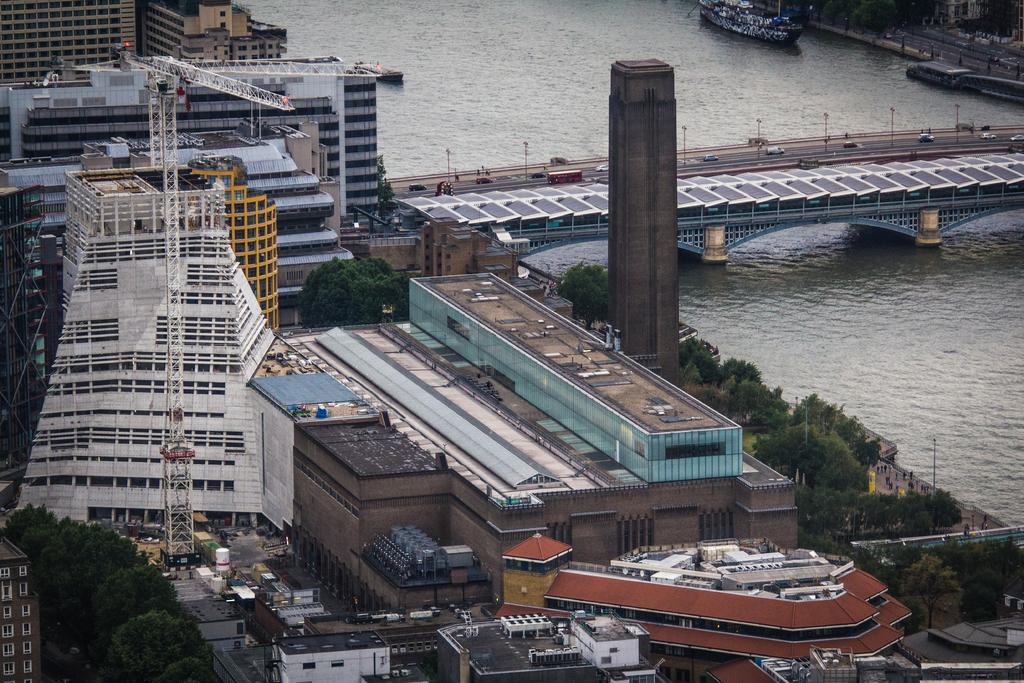What type of view is shown in the image? The image is an aerial view. What structures can be seen in the image? There are buildings in the image. What type of transportation infrastructure is visible? There is a road and a bridge visible in the image. What natural elements are present in the image? Trees and water are visible in the image. What activity is taking place on the water? Boats are moving on the water in the image. What type of bed can be seen in the image? There is no bed present in the image; it is an aerial view of a landscape with buildings, roads, bridges, trees, water, and boats. What star is shining brightly in the image? There is no star visible in the image, as it is an aerial view of a landscape with buildings, roads, bridges, trees, water, and boats. 